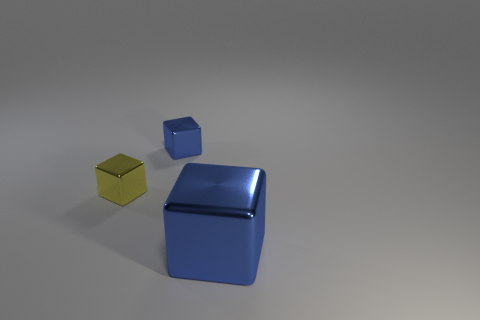Add 1 green matte spheres. How many objects exist? 4 Add 3 tiny blue things. How many tiny blue things are left? 4 Add 1 tiny red cylinders. How many tiny red cylinders exist? 1 Subtract 0 red spheres. How many objects are left? 3 Subtract all blue things. Subtract all red cubes. How many objects are left? 1 